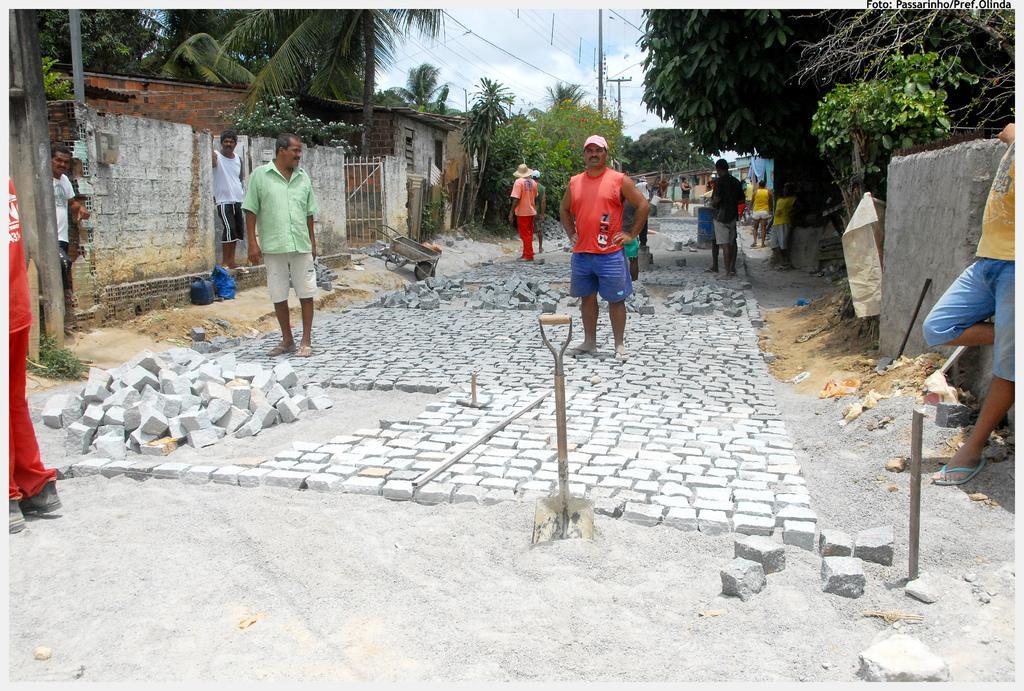Please provide a concise description of this image. In the center of the image we can see people standing. At the bottom there are cobblestones. On the right there is a wall. In the background there are trees, shed, poles, wires and sky. 